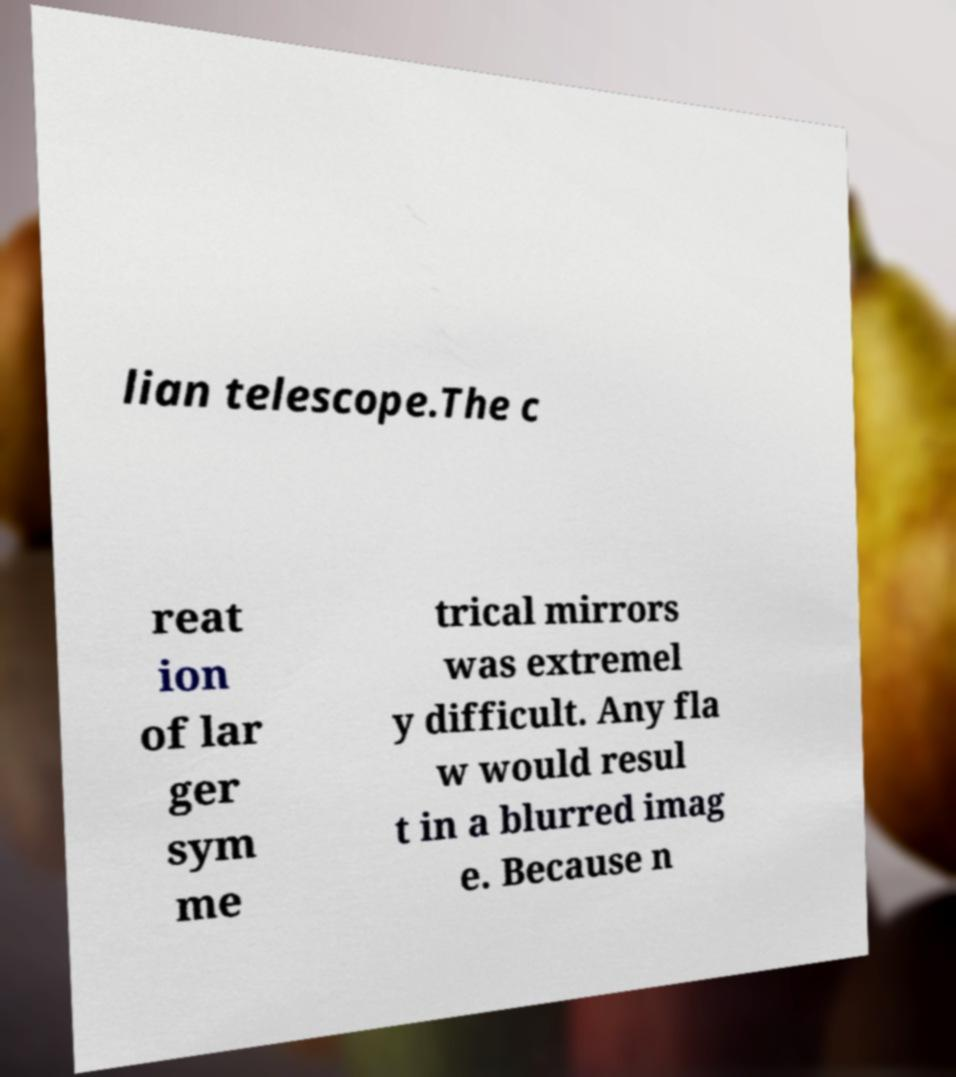There's text embedded in this image that I need extracted. Can you transcribe it verbatim? lian telescope.The c reat ion of lar ger sym me trical mirrors was extremel y difficult. Any fla w would resul t in a blurred imag e. Because n 